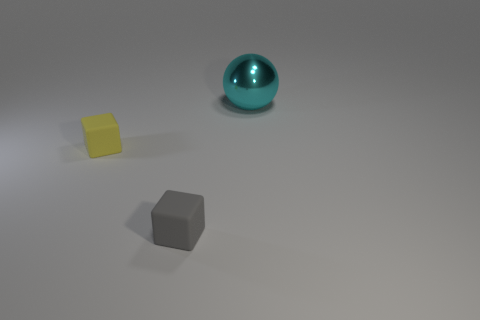Can you guess what the purpose of this arrangement might be? This arrangement may be part of a visual composition exercise, possibly intended for artistic or educational purposes. Each object's distinct texture and color could serve to demonstrate how different materials interact with light. Alternatively, it may be a simple display of 3D rendering, showcasing the creator's ability to depict various geometric shapes and surfaces. 